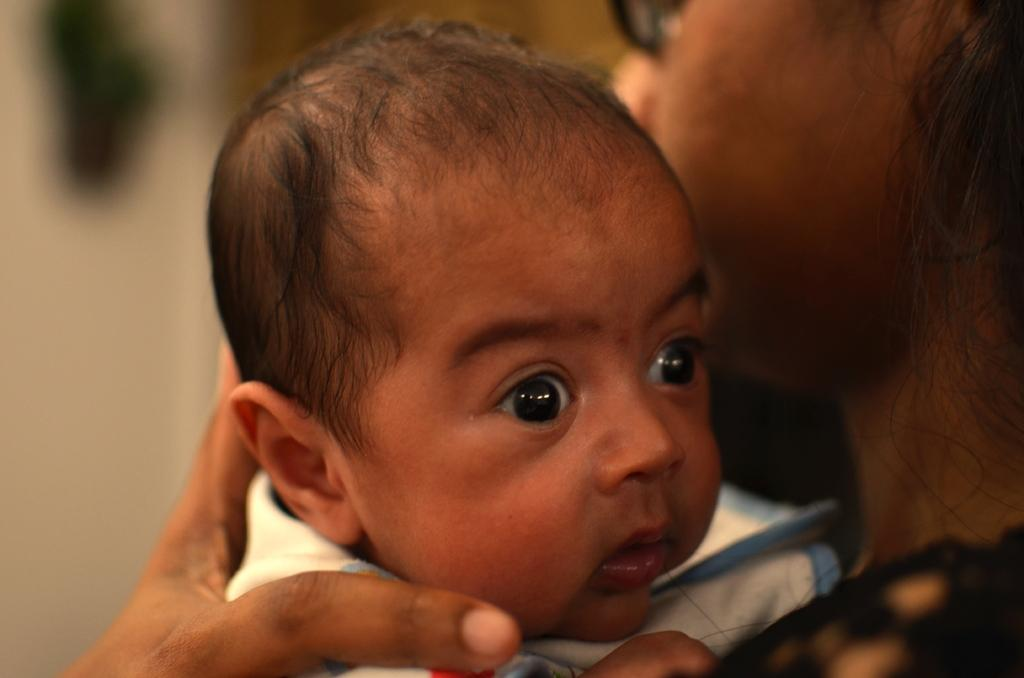What is the main subject of the image? The main subject of the image is a woman. What is the woman doing in the image? The woman is carrying a baby. How many hands does the woman have in the image? The number of hands the woman has cannot be determined from the image. Is the woman riding a bike in the image? There is no bike present in the image. What tool is the woman using to fix something in the image? There is no tool, such as a wrench, present in the image. 